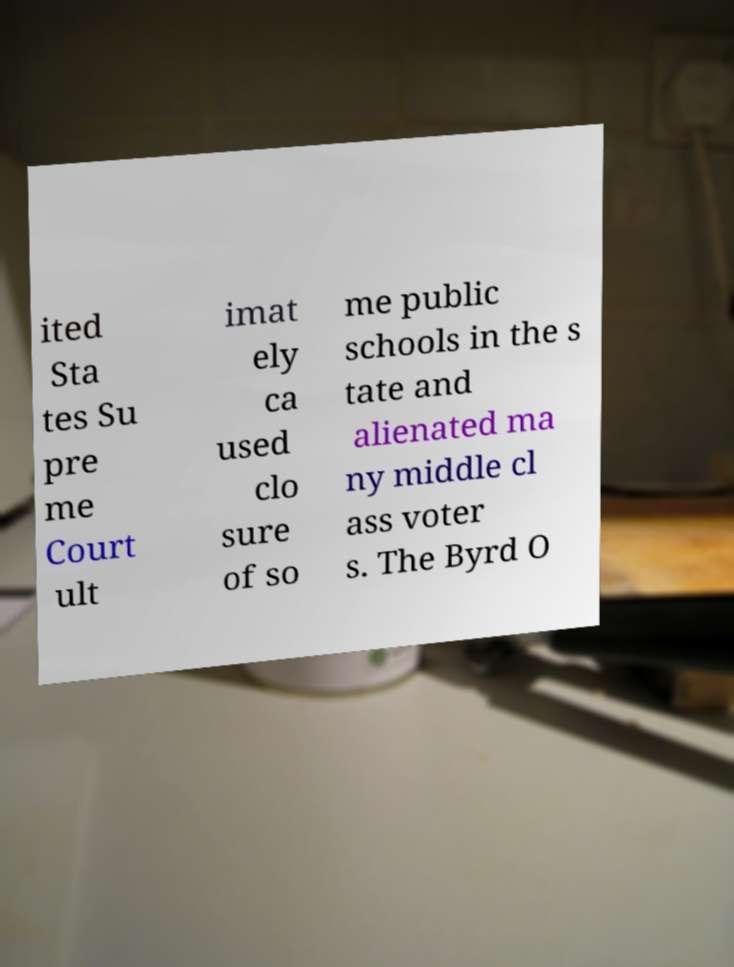Please read and relay the text visible in this image. What does it say? ited Sta tes Su pre me Court ult imat ely ca used clo sure of so me public schools in the s tate and alienated ma ny middle cl ass voter s. The Byrd O 